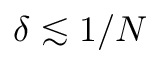Convert formula to latex. <formula><loc_0><loc_0><loc_500><loc_500>\delta \lesssim 1 / N</formula> 